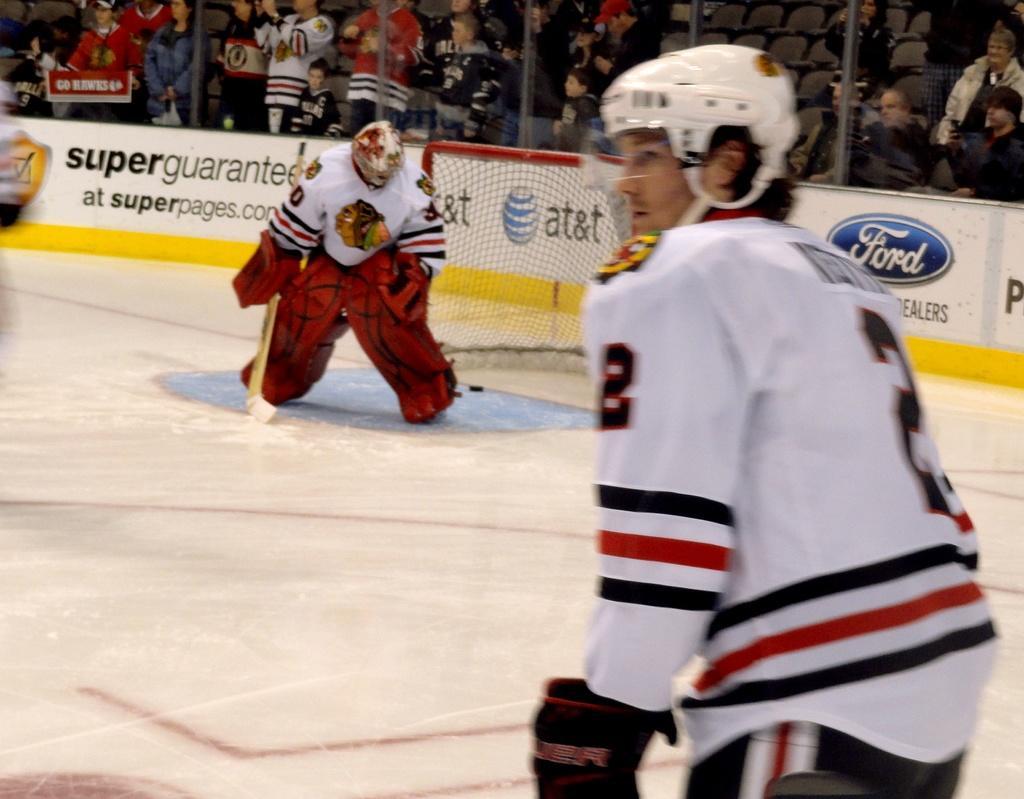In one or two sentences, can you explain what this image depicts? In this image, there are a few people. We can see the ground. We can also see some boards with text. We can see the net and the fence. There are a few chairs. 